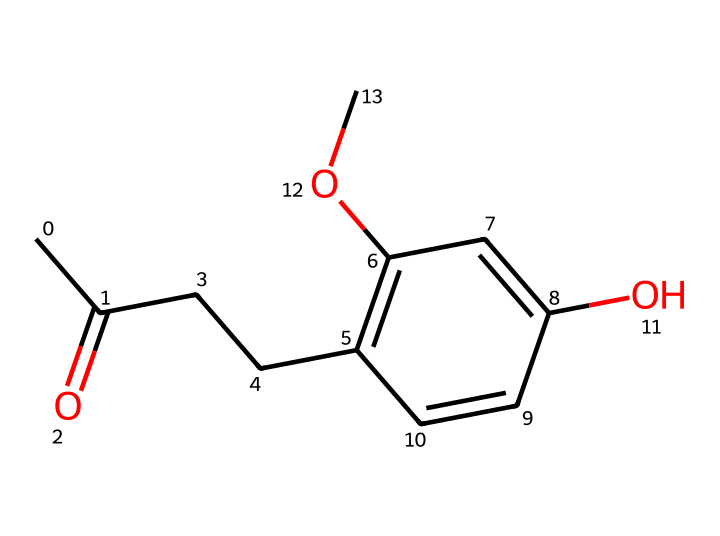What is the molecular formula of raspberry ketone? To determine the molecular formula, we count the number of each type of atom in the SMILES representation. From the SMILES provided, there are 10 carbon atoms, 10 hydrogen atoms, and 3 oxygen atoms, indicating the molecular formula is C10H10O3.
Answer: C10H10O3 How many rings are present in the structure? By examining the SMILES representation, we identify the presence of a cyclic structure. The numbers in the SMILES indicate the start and end of the ring; specifically, we see 'C1' and 'C1' which denote a ring. Therefore, there is one ring present.
Answer: 1 Which functional group is primarily featured in raspberry ketone? The characteristic functional group in this compound is the ketone group, identifiable through the carbonyl group (C=O) in the structure. The presence of this group indicates that it is a ketone.
Answer: ketone What is the degree of unsaturation in raspberry ketone? The degree of unsaturation can be calculated based on the formula (2C + 2 + N - H - X)/2, where C is the number of carbons, H is the number of hydrogens, N is nitrogens, and X is halogens. With 10 carbons and 10 hydrogens, we find that the degree of unsaturation is 4, indicating a combination of rings and multiple bonds.
Answer: 4 What is the common use of raspberry ketone? Raspberry ketone is commonly used as a flavoring agent and in the formulation of perfumes due to its pleasant smell. It adds a fruity aroma, making it popular in food and cosmetic products.
Answer: flavoring agent 